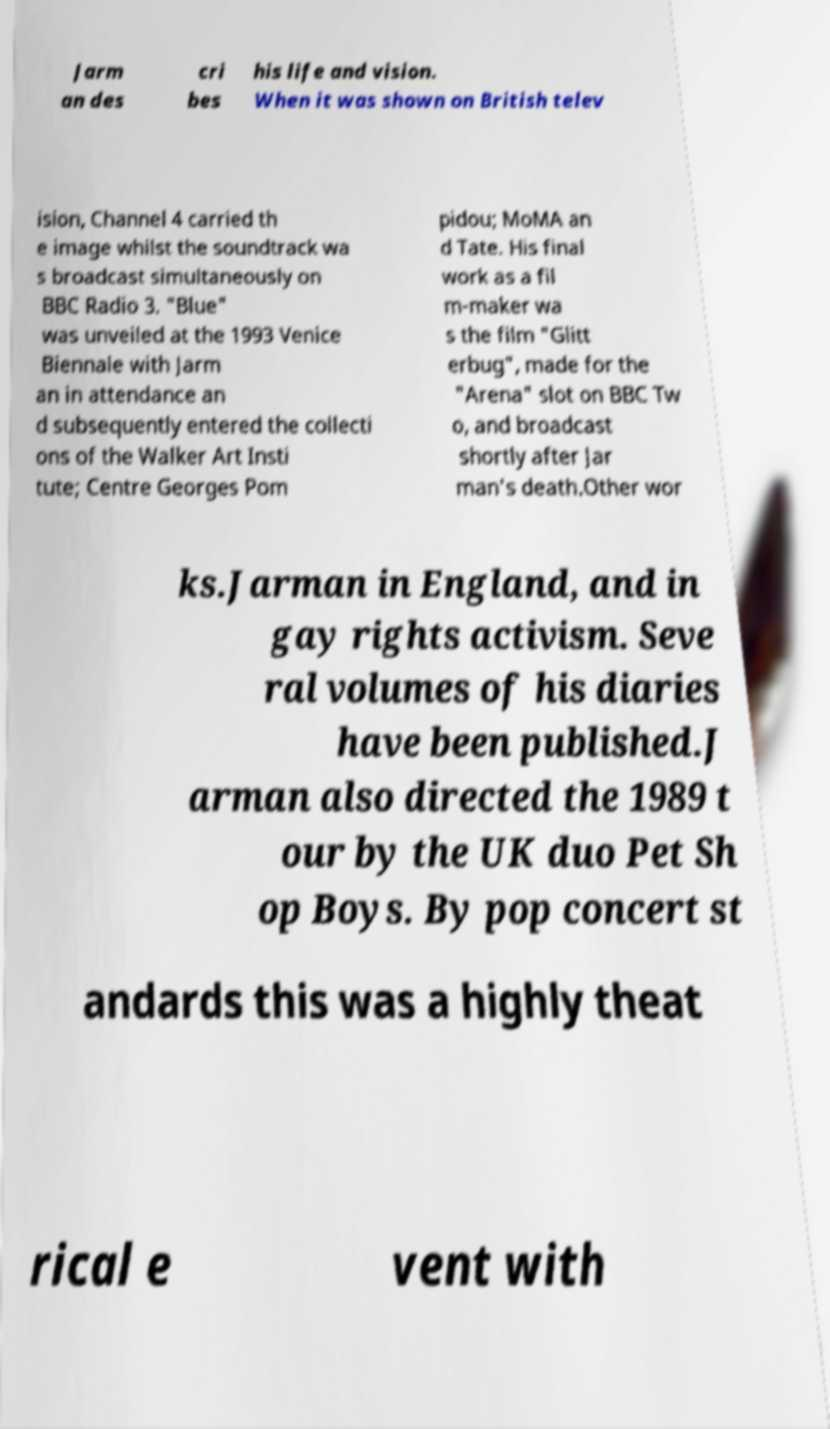I need the written content from this picture converted into text. Can you do that? Jarm an des cri bes his life and vision. When it was shown on British telev ision, Channel 4 carried th e image whilst the soundtrack wa s broadcast simultaneously on BBC Radio 3. "Blue" was unveiled at the 1993 Venice Biennale with Jarm an in attendance an d subsequently entered the collecti ons of the Walker Art Insti tute; Centre Georges Pom pidou; MoMA an d Tate. His final work as a fil m-maker wa s the film "Glitt erbug", made for the "Arena" slot on BBC Tw o, and broadcast shortly after Jar man's death.Other wor ks.Jarman in England, and in gay rights activism. Seve ral volumes of his diaries have been published.J arman also directed the 1989 t our by the UK duo Pet Sh op Boys. By pop concert st andards this was a highly theat rical e vent with 